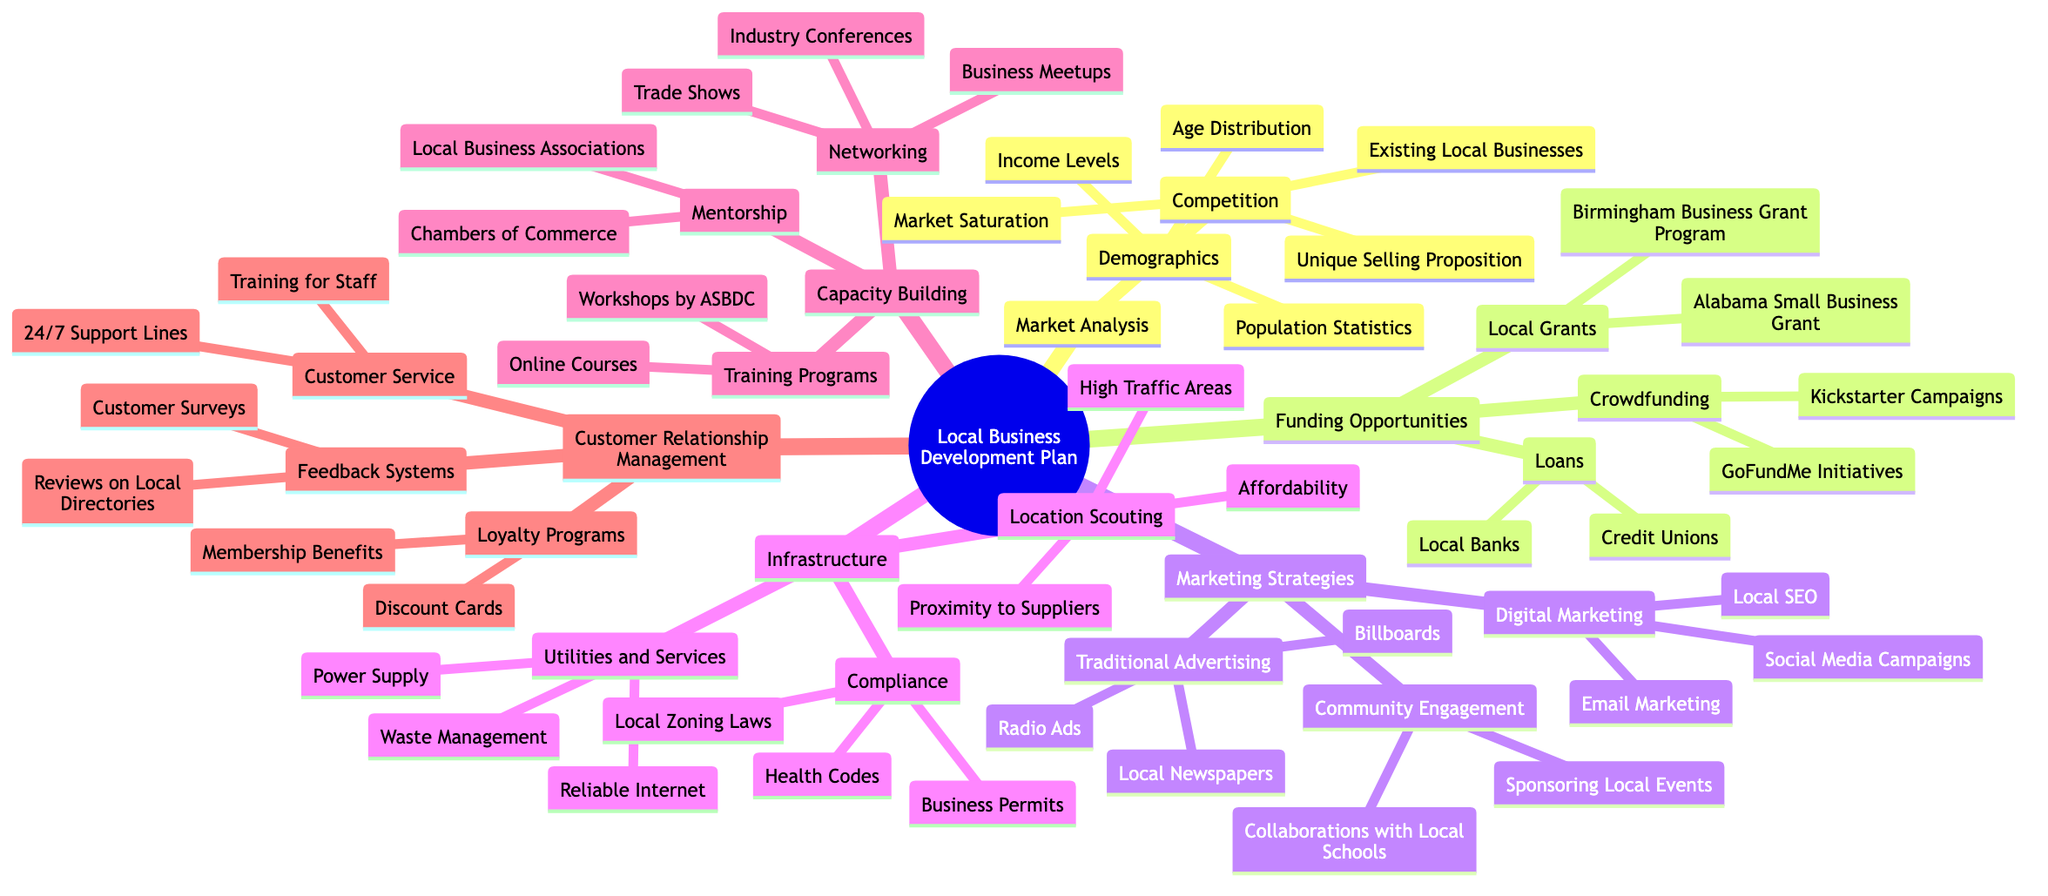What are the three sections of Market Analysis? From the diagram, under the "Market Analysis" node, there are two branches: "Demographics" and "Competition." "Demographics" includes population statistics, income levels, and age distribution, while "Competition" has existing local businesses, market saturation, and unique selling proposition. Thus, the three sections are Demographics, Income Levels, Age Distribution.
Answer: Demographics, Competition How many funding opportunities are listed? The "Funding Opportunities" section lists three main categories: "Local Grants," "Loans," and "Crowdfunding." Each of these categories further breaks down into sub-items. However, the number of distinct categories that represent funding opportunities in this map is three.
Answer: 3 What are two types of loans mentioned? Under the "Loans" section of "Funding Opportunities," there are two specified sub-categories: "Local Banks" and "Credit Unions." These represent the two types of loans available.
Answer: Local Banks, Credit Unions Which marketing strategy focuses on Local SEO? "Digital Marketing," a sub-section under "Marketing Strategies," includes "Local SEO" as one of its components. The section specifically addresses the tools and techniques businesses may use in the digital realm.
Answer: Digital Marketing How is customer feedback gathered according to the diagram? The "Customer Relationship Management" section lists "Feedback Systems," which includes "Customer Surveys" and "Reviews on Local Business Directories" as methods to gather feedback from customers, highlighting the importance of understanding customer satisfaction and preferences.
Answer: Customer Surveys, Reviews on Local Business Directories What are two training programs available for capacity building? Within the "Capacity Building" section, the "Training Programs" node cites two sources: "Workshops by Alabama Small Business Development Center" and "Online Courses." These represent opportunities for business skills enhancement and professional development.
Answer: Workshops by Alabama Small Business Development Center, Online Courses What does the Infrastructure section say about location scouting? The "Infrastructure" section breaks down into "Location Scouting," which further includes "High Traffic Areas," "Affordability," and "Proximity to Suppliers." This addresses where businesses should consider establishing themselves for optimal visibility and accessibility.
Answer: High Traffic Areas, Affordability, Proximity to Suppliers How many feedback system methods are identified? The "Feedback Systems" in "Customer Relationship Management" has two identified methods: "Customer Surveys" and "Reviews on Local Business Directories." This means there are two primary approaches suggested for obtaining feedback.
Answer: 2 What type of community engagement is suggested? The "Marketing Strategies" section refers to "Community Engagement," which includes "Sponsoring Local Events" and "Collaborations with Local Schools." These activities are aimed at increasing local visibility and building relationships within the community.
Answer: Sponsoring Local Events, Collaborations with Local Schools 